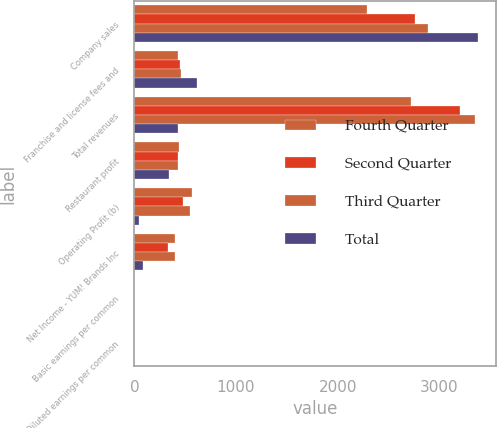Convert chart to OTSL. <chart><loc_0><loc_0><loc_500><loc_500><stacked_bar_chart><ecel><fcel>Company sales<fcel>Franchise and license fees and<fcel>Total revenues<fcel>Restaurant profit<fcel>Operating Profit (b)<fcel>Net Income - YUM! Brands Inc<fcel>Basic earnings per common<fcel>Diluted earnings per common<nl><fcel>Fourth Quarter<fcel>2292<fcel>432<fcel>2724<fcel>441<fcel>571<fcel>399<fcel>0.89<fcel>0.87<nl><fcel>Second Quarter<fcel>2758<fcel>446<fcel>3204<fcel>428<fcel>479<fcel>334<fcel>0.75<fcel>0.73<nl><fcel>Third Quarter<fcel>2891<fcel>463<fcel>3354<fcel>429<fcel>550<fcel>404<fcel>0.91<fcel>0.89<nl><fcel>Total<fcel>3383<fcel>614<fcel>429<fcel>344<fcel>43<fcel>86<fcel>0.2<fcel>0.2<nl></chart> 